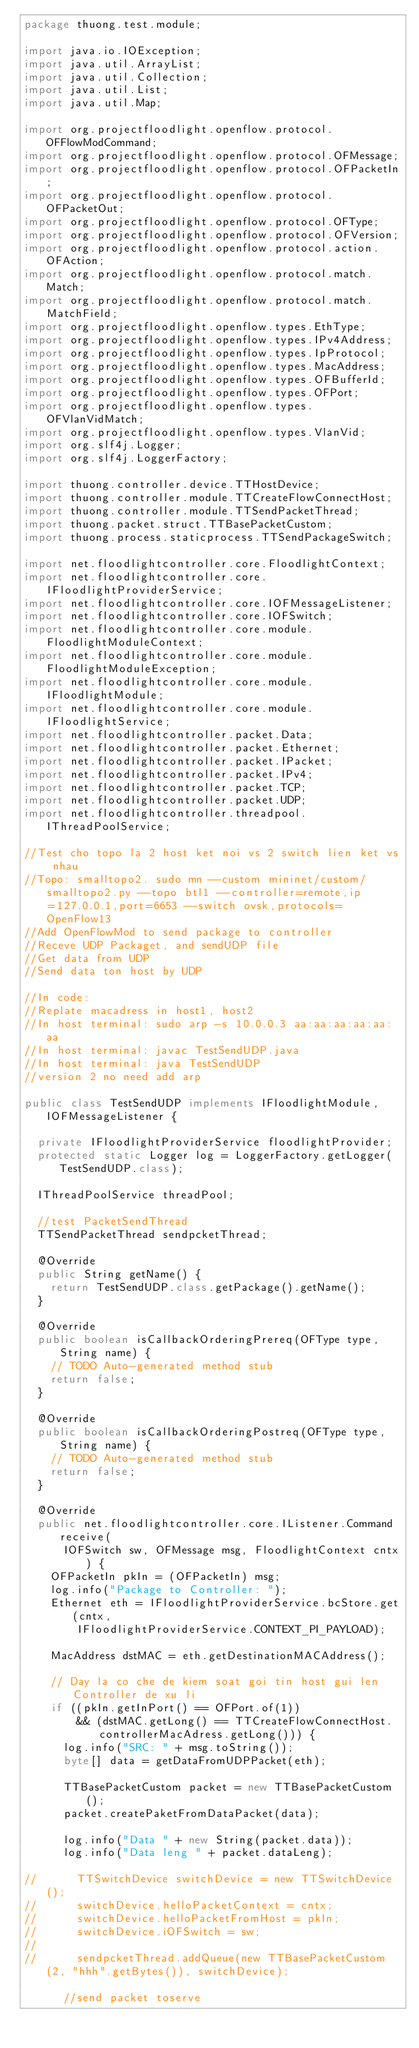<code> <loc_0><loc_0><loc_500><loc_500><_Java_>package thuong.test.module;

import java.io.IOException;
import java.util.ArrayList;
import java.util.Collection;
import java.util.List;
import java.util.Map;

import org.projectfloodlight.openflow.protocol.OFFlowModCommand;
import org.projectfloodlight.openflow.protocol.OFMessage;
import org.projectfloodlight.openflow.protocol.OFPacketIn;
import org.projectfloodlight.openflow.protocol.OFPacketOut;
import org.projectfloodlight.openflow.protocol.OFType;
import org.projectfloodlight.openflow.protocol.OFVersion;
import org.projectfloodlight.openflow.protocol.action.OFAction;
import org.projectfloodlight.openflow.protocol.match.Match;
import org.projectfloodlight.openflow.protocol.match.MatchField;
import org.projectfloodlight.openflow.types.EthType;
import org.projectfloodlight.openflow.types.IPv4Address;
import org.projectfloodlight.openflow.types.IpProtocol;
import org.projectfloodlight.openflow.types.MacAddress;
import org.projectfloodlight.openflow.types.OFBufferId;
import org.projectfloodlight.openflow.types.OFPort;
import org.projectfloodlight.openflow.types.OFVlanVidMatch;
import org.projectfloodlight.openflow.types.VlanVid;
import org.slf4j.Logger;
import org.slf4j.LoggerFactory;

import thuong.controller.device.TTHostDevice;
import thuong.controller.module.TTCreateFlowConnectHost;
import thuong.controller.module.TTSendPacketThread;
import thuong.packet.struct.TTBasePacketCustom;
import thuong.process.staticprocess.TTSendPackageSwitch;

import net.floodlightcontroller.core.FloodlightContext;
import net.floodlightcontroller.core.IFloodlightProviderService;
import net.floodlightcontroller.core.IOFMessageListener;
import net.floodlightcontroller.core.IOFSwitch;
import net.floodlightcontroller.core.module.FloodlightModuleContext;
import net.floodlightcontroller.core.module.FloodlightModuleException;
import net.floodlightcontroller.core.module.IFloodlightModule;
import net.floodlightcontroller.core.module.IFloodlightService;
import net.floodlightcontroller.packet.Data;
import net.floodlightcontroller.packet.Ethernet;
import net.floodlightcontroller.packet.IPacket;
import net.floodlightcontroller.packet.IPv4;
import net.floodlightcontroller.packet.TCP;
import net.floodlightcontroller.packet.UDP;
import net.floodlightcontroller.threadpool.IThreadPoolService;

//Test cho topo la 2 host ket noi vs 2 switch lien ket vs nhau
//Topo: smalltopo2. sudo mn --custom mininet/custom/smalltopo2.py --topo btl1 --controller=remote,ip=127.0.0.1,port=6653 --switch ovsk,protocols=OpenFlow13
//Add OpenFlowMod to send package to controller
//Receve UDP Packaget, and sendUDP file
//Get data from UDP
//Send data ton host by UDP 

//In code:
//Replate macadress in host1, host2
//In host terminal: sudo arp -s 10.0.0.3 aa:aa:aa:aa:aa:aa
//In host terminal: javac TestSendUDP.java
//In host terminal: java TestSendUDP
//version 2 no need add arp

public class TestSendUDP implements IFloodlightModule, IOFMessageListener {

	private IFloodlightProviderService floodlightProvider;
	protected static Logger log = LoggerFactory.getLogger(TestSendUDP.class);

	IThreadPoolService threadPool;

	//test PacketSendThread
	TTSendPacketThread sendpcketThread;
	
	@Override
	public String getName() {
		return TestSendUDP.class.getPackage().getName();
	}

	@Override
	public boolean isCallbackOrderingPrereq(OFType type, String name) {
		// TODO Auto-generated method stub
		return false;
	}

	@Override
	public boolean isCallbackOrderingPostreq(OFType type, String name) {
		// TODO Auto-generated method stub
		return false;
	}

	@Override
	public net.floodlightcontroller.core.IListener.Command receive(
			IOFSwitch sw, OFMessage msg, FloodlightContext cntx) {
		OFPacketIn pkIn = (OFPacketIn) msg;
		log.info("Package to Controller: ");
		Ethernet eth = IFloodlightProviderService.bcStore.get(cntx,
				IFloodlightProviderService.CONTEXT_PI_PAYLOAD);

		MacAddress dstMAC = eth.getDestinationMACAddress();

		// Day la co che de kiem soat goi tin host gui len Controller de xu li
		if ((pkIn.getInPort() == OFPort.of(1))
				&& (dstMAC.getLong() == TTCreateFlowConnectHost.controllerMacAdress.getLong())) {
			log.info("SRC: " + msg.toString());
			byte[] data = getDataFromUDPPacket(eth);
			
			TTBasePacketCustom packet = new TTBasePacketCustom();
			packet.createPaketFromDataPacket(data);
			
			log.info("Data " + new String(packet.data));
			log.info("Data leng " + packet.dataLeng);

//			TTSwitchDevice switchDevice = new TTSwitchDevice();
//			switchDevice.helloPacketContext = cntx;
//			switchDevice.helloPacketFromHost = pkIn;
//			switchDevice.iOFSwitch = sw;
//			
//			sendpcketThread.addQueue(new TTBasePacketCustom(2, "hhh".getBytes()), switchDevice);
			
			//send packet toserve</code> 